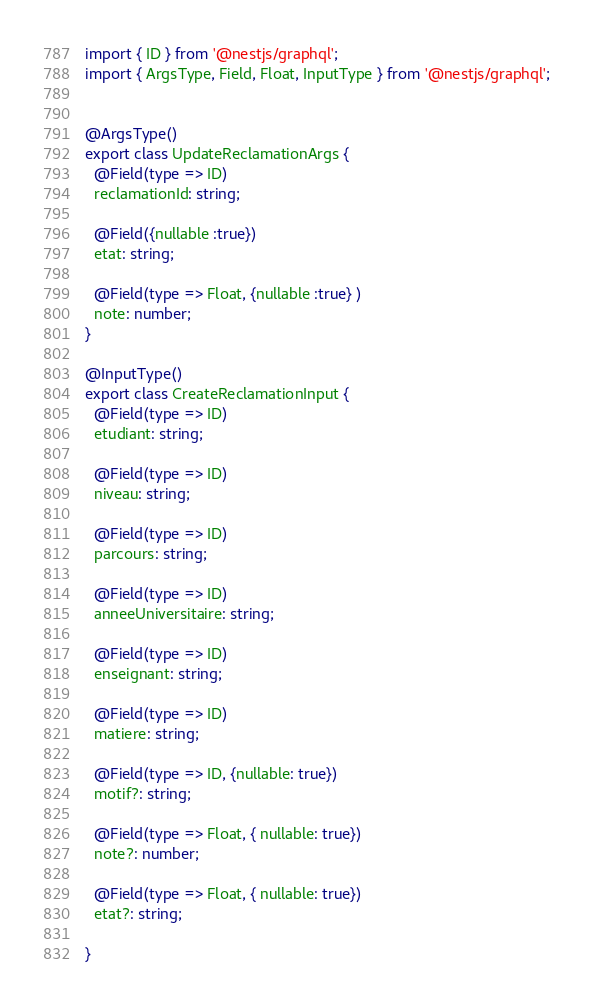Convert code to text. <code><loc_0><loc_0><loc_500><loc_500><_TypeScript_>import { ID } from '@nestjs/graphql';
import { ArgsType, Field, Float, InputType } from '@nestjs/graphql';


@ArgsType()
export class UpdateReclamationArgs {
  @Field(type => ID)
  reclamationId: string;

  @Field({nullable :true})
  etat: string;

  @Field(type => Float, {nullable :true} )
  note: number;
}

@InputType()
export class CreateReclamationInput {
  @Field(type => ID)
  etudiant: string;

  @Field(type => ID)
  niveau: string;

  @Field(type => ID)
  parcours: string;

  @Field(type => ID)
  anneeUniversitaire: string;

  @Field(type => ID)
  enseignant: string;
  
  @Field(type => ID)
  matiere: string;

  @Field(type => ID, {nullable: true})
  motif?: string;
  
  @Field(type => Float, { nullable: true})
  note?: number;

  @Field(type => Float, { nullable: true})
  etat?: string;

}
</code> 